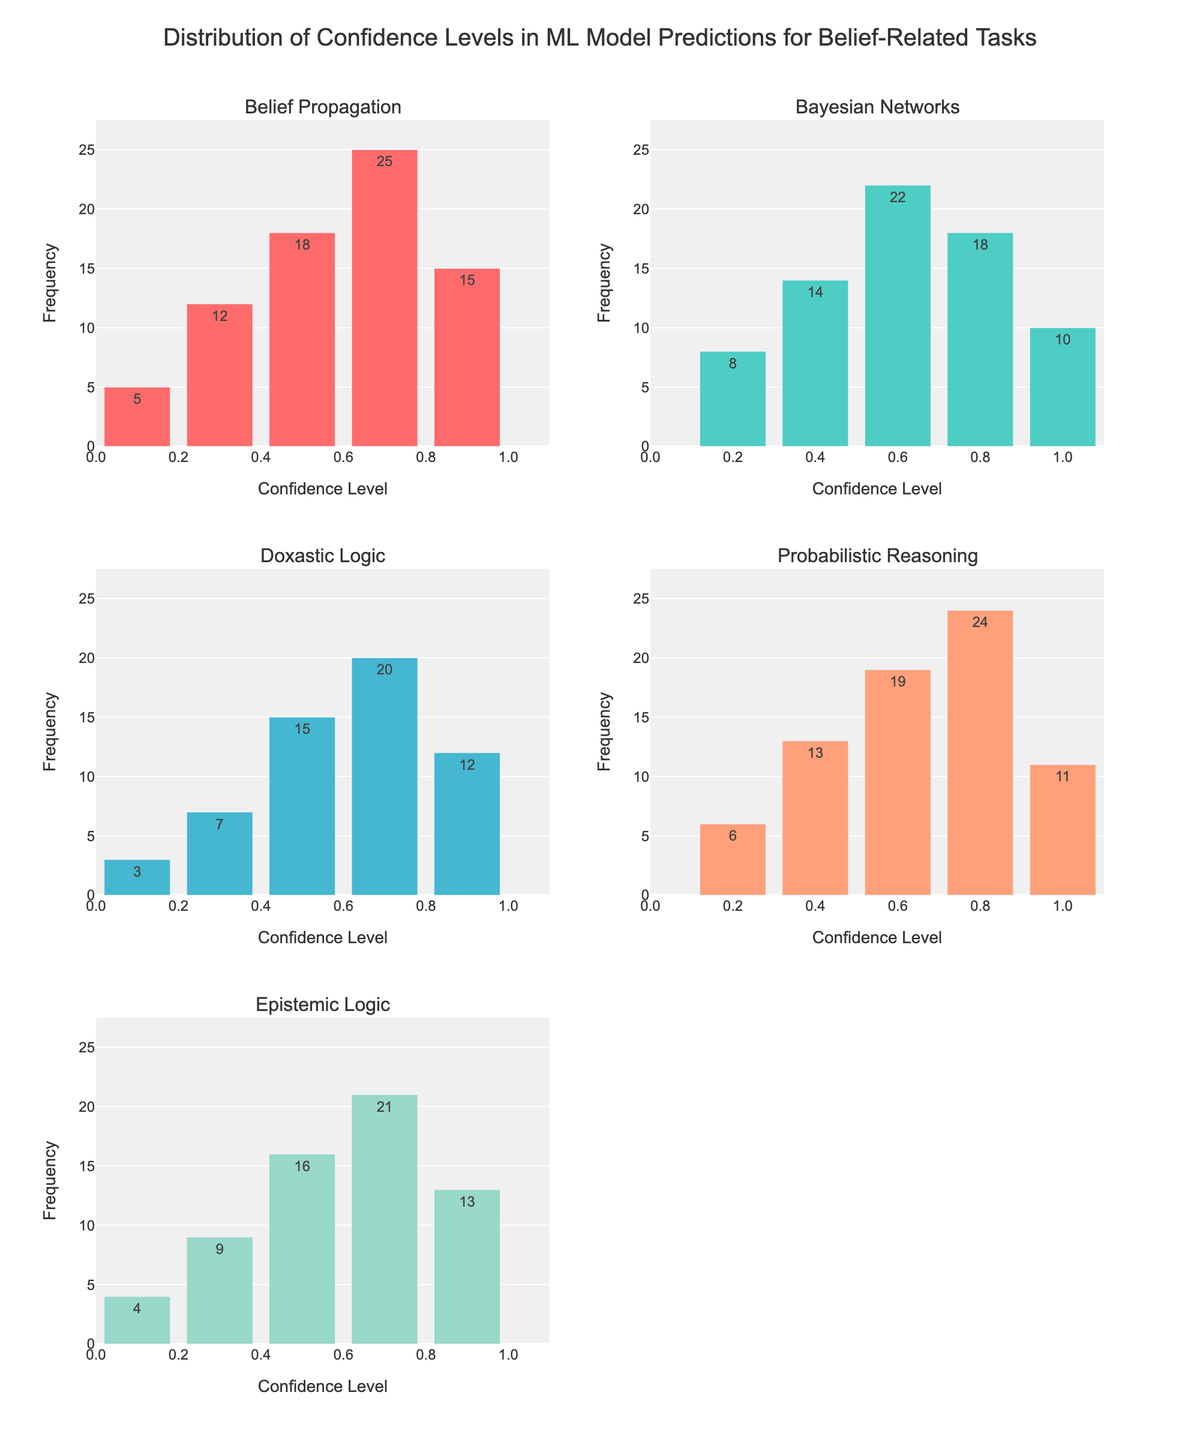What does the title of the figure indicate? The title is positioned at the top center of the figure and states "Distribution of Confidence Levels in ML Model Predictions for Belief-Related Tasks". This title indicates that the figure is showing the distribution of how confident a machine learning model is in its predictions related to different belief-related tasks.
Answer: The distribution of confidence levels in ML model predictions What is the highest frequency observed for any task? Looking at each subplot for different tasks, the highest frequency is visible in the subplot for "Belief Propagation" at a confidence level of 0.7, where the frequency is 25.
Answer: 25 Which color represents the task "Bayesian Networks"? Each subplot corresponds to a different task, and "Bayesian Networks" is indicated by the second subplot in the top row using a cyan-blue color.
Answer: Cyan-blue What is the combined frequency of confidence levels 0.5 for "Belief Propagation" and "Doxastic Logic"? The subplot for "Belief Propagation" shows a frequency of 18 at confidence level 0.5, and the subplot for "Doxastic Logic" shows a frequency of 15 at the same confidence level. Adding these together gives 18 + 15 = 33.
Answer: 33 Which task has the lowest frequency for confidence level 0.3? By observing the subplots, the task "Doxastic Logic" has the lowest frequency at confidence level 0.3, which is 7.
Answer: Doxastic Logic What is the average frequency for confidence levels 0.6 across all tasks? The frequencies for 0.6 confidence in each subplot are: "Belief Propagation" (18), "Bayesian Networks" (22), "Doxastic Logic" (15), "Probabilistic Reasoning" (19), and "Epistemic Logic" (16). Adding these: 18 + 22 + 15 + 19 + 16 = 90. Dividing by the number of tasks (5) gives 90 / 5 = 18.
Answer: 18 What is the largest frequency difference between any two confidence levels within a single task? The largest single difference is within "Probabilistic Reasoning" between confidence levels 0.8 (24) and 0.2 (6), with a difference of 24 - 6 = 18.
Answer: 18 Which task has the highest frequency at the highest confidence level? In the subplot for "Bayesian Networks", the frequency at the highest confidence level (1.0) is 10, which is the highest among all tasks at their respective highest confidence levels.
Answer: Bayesian Networks How many unique confidence levels are shown in the subplots? Each subplot shows the same set of unique confidence levels as indicated by the tick marks along the x-axis. These confidence levels are: 0.1, 0.2, 0.3, 0.4, 0.5, 0.6, 0.7, 0.8, 0.9, and 1.0.
Answer: 10 